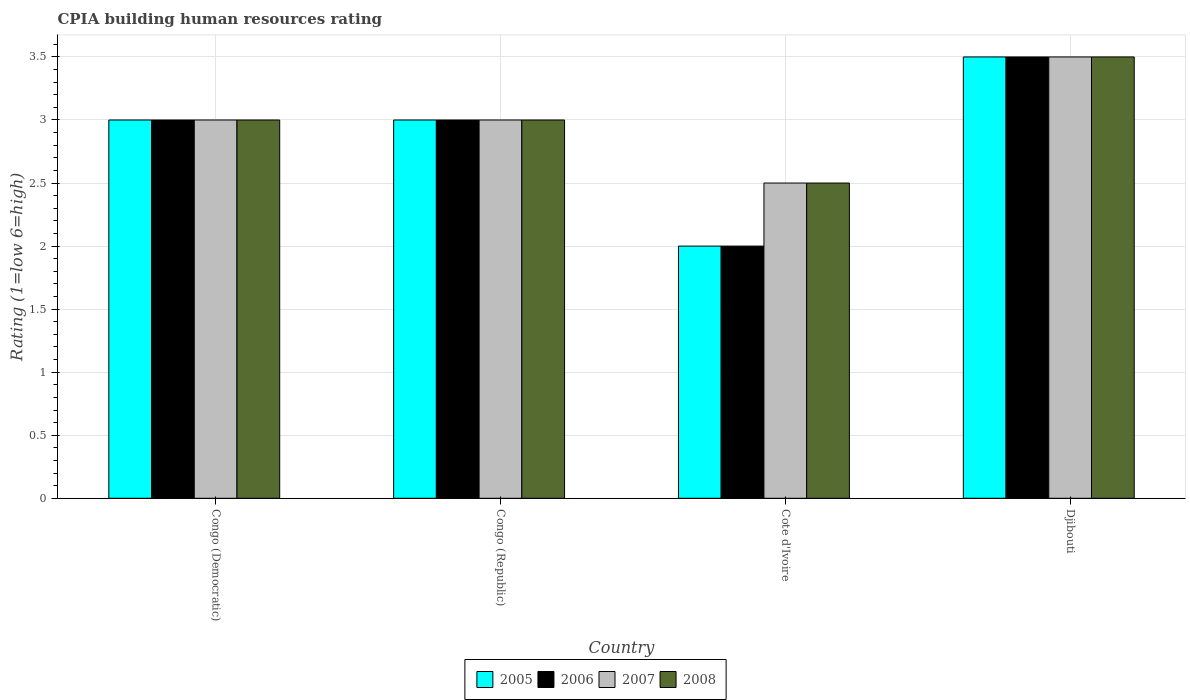How many bars are there on the 2nd tick from the left?
Provide a short and direct response. 4. What is the label of the 2nd group of bars from the left?
Provide a short and direct response. Congo (Republic). What is the CPIA rating in 2008 in Djibouti?
Your response must be concise. 3.5. In which country was the CPIA rating in 2007 maximum?
Keep it short and to the point. Djibouti. In which country was the CPIA rating in 2005 minimum?
Offer a terse response. Cote d'Ivoire. What is the difference between the CPIA rating in 2006 in Congo (Democratic) and that in Congo (Republic)?
Provide a short and direct response. 0. What is the difference between the CPIA rating in 2007 in Djibouti and the CPIA rating in 2005 in Congo (Democratic)?
Your response must be concise. 0.5. What is the average CPIA rating in 2008 per country?
Make the answer very short. 3. In how many countries, is the CPIA rating in 2007 greater than 3.1?
Offer a very short reply. 1. What is the ratio of the CPIA rating in 2006 in Congo (Democratic) to that in Djibouti?
Provide a short and direct response. 0.86. What is the difference between the highest and the second highest CPIA rating in 2008?
Provide a short and direct response. -0.5. What is the difference between the highest and the lowest CPIA rating in 2005?
Provide a short and direct response. 1.5. In how many countries, is the CPIA rating in 2005 greater than the average CPIA rating in 2005 taken over all countries?
Provide a succinct answer. 3. What does the 1st bar from the left in Congo (Republic) represents?
Give a very brief answer. 2005. What does the 2nd bar from the right in Djibouti represents?
Your response must be concise. 2007. What is the difference between two consecutive major ticks on the Y-axis?
Provide a succinct answer. 0.5. Does the graph contain grids?
Your response must be concise. Yes. What is the title of the graph?
Provide a short and direct response. CPIA building human resources rating. What is the label or title of the X-axis?
Provide a succinct answer. Country. What is the Rating (1=low 6=high) in 2006 in Congo (Democratic)?
Your answer should be compact. 3. What is the Rating (1=low 6=high) in 2005 in Congo (Republic)?
Offer a terse response. 3. What is the Rating (1=low 6=high) in 2008 in Congo (Republic)?
Offer a terse response. 3. What is the Rating (1=low 6=high) of 2005 in Cote d'Ivoire?
Give a very brief answer. 2. What is the Rating (1=low 6=high) of 2006 in Cote d'Ivoire?
Your answer should be very brief. 2. What is the Rating (1=low 6=high) of 2008 in Cote d'Ivoire?
Your response must be concise. 2.5. What is the Rating (1=low 6=high) of 2005 in Djibouti?
Your answer should be very brief. 3.5. Across all countries, what is the maximum Rating (1=low 6=high) of 2005?
Your answer should be very brief. 3.5. Across all countries, what is the minimum Rating (1=low 6=high) of 2005?
Provide a short and direct response. 2. Across all countries, what is the minimum Rating (1=low 6=high) in 2007?
Offer a very short reply. 2.5. Across all countries, what is the minimum Rating (1=low 6=high) in 2008?
Keep it short and to the point. 2.5. What is the total Rating (1=low 6=high) of 2005 in the graph?
Ensure brevity in your answer.  11.5. What is the total Rating (1=low 6=high) in 2008 in the graph?
Provide a succinct answer. 12. What is the difference between the Rating (1=low 6=high) of 2005 in Congo (Democratic) and that in Congo (Republic)?
Make the answer very short. 0. What is the difference between the Rating (1=low 6=high) in 2007 in Congo (Democratic) and that in Congo (Republic)?
Offer a very short reply. 0. What is the difference between the Rating (1=low 6=high) of 2008 in Congo (Democratic) and that in Congo (Republic)?
Keep it short and to the point. 0. What is the difference between the Rating (1=low 6=high) of 2005 in Congo (Democratic) and that in Cote d'Ivoire?
Make the answer very short. 1. What is the difference between the Rating (1=low 6=high) in 2006 in Congo (Democratic) and that in Djibouti?
Provide a succinct answer. -0.5. What is the difference between the Rating (1=low 6=high) of 2008 in Congo (Democratic) and that in Djibouti?
Your answer should be very brief. -0.5. What is the difference between the Rating (1=low 6=high) in 2005 in Congo (Republic) and that in Cote d'Ivoire?
Give a very brief answer. 1. What is the difference between the Rating (1=low 6=high) in 2006 in Congo (Republic) and that in Cote d'Ivoire?
Give a very brief answer. 1. What is the difference between the Rating (1=low 6=high) in 2007 in Congo (Republic) and that in Cote d'Ivoire?
Provide a succinct answer. 0.5. What is the difference between the Rating (1=low 6=high) of 2005 in Congo (Republic) and that in Djibouti?
Keep it short and to the point. -0.5. What is the difference between the Rating (1=low 6=high) in 2006 in Congo (Republic) and that in Djibouti?
Provide a short and direct response. -0.5. What is the difference between the Rating (1=low 6=high) of 2007 in Congo (Republic) and that in Djibouti?
Make the answer very short. -0.5. What is the difference between the Rating (1=low 6=high) of 2008 in Congo (Republic) and that in Djibouti?
Offer a very short reply. -0.5. What is the difference between the Rating (1=low 6=high) in 2005 in Cote d'Ivoire and that in Djibouti?
Ensure brevity in your answer.  -1.5. What is the difference between the Rating (1=low 6=high) in 2006 in Cote d'Ivoire and that in Djibouti?
Provide a succinct answer. -1.5. What is the difference between the Rating (1=low 6=high) of 2008 in Cote d'Ivoire and that in Djibouti?
Your response must be concise. -1. What is the difference between the Rating (1=low 6=high) of 2005 in Congo (Democratic) and the Rating (1=low 6=high) of 2008 in Congo (Republic)?
Ensure brevity in your answer.  0. What is the difference between the Rating (1=low 6=high) of 2006 in Congo (Democratic) and the Rating (1=low 6=high) of 2008 in Congo (Republic)?
Keep it short and to the point. 0. What is the difference between the Rating (1=low 6=high) of 2007 in Congo (Democratic) and the Rating (1=low 6=high) of 2008 in Congo (Republic)?
Give a very brief answer. 0. What is the difference between the Rating (1=low 6=high) of 2005 in Congo (Democratic) and the Rating (1=low 6=high) of 2006 in Cote d'Ivoire?
Your answer should be very brief. 1. What is the difference between the Rating (1=low 6=high) of 2005 in Congo (Democratic) and the Rating (1=low 6=high) of 2007 in Cote d'Ivoire?
Keep it short and to the point. 0.5. What is the difference between the Rating (1=low 6=high) in 2005 in Congo (Democratic) and the Rating (1=low 6=high) in 2008 in Cote d'Ivoire?
Ensure brevity in your answer.  0.5. What is the difference between the Rating (1=low 6=high) of 2006 in Congo (Democratic) and the Rating (1=low 6=high) of 2007 in Cote d'Ivoire?
Provide a succinct answer. 0.5. What is the difference between the Rating (1=low 6=high) of 2006 in Congo (Democratic) and the Rating (1=low 6=high) of 2008 in Cote d'Ivoire?
Keep it short and to the point. 0.5. What is the difference between the Rating (1=low 6=high) in 2007 in Congo (Democratic) and the Rating (1=low 6=high) in 2008 in Cote d'Ivoire?
Provide a short and direct response. 0.5. What is the difference between the Rating (1=low 6=high) in 2005 in Congo (Democratic) and the Rating (1=low 6=high) in 2006 in Djibouti?
Provide a short and direct response. -0.5. What is the difference between the Rating (1=low 6=high) of 2006 in Congo (Democratic) and the Rating (1=low 6=high) of 2007 in Djibouti?
Provide a succinct answer. -0.5. What is the difference between the Rating (1=low 6=high) of 2006 in Congo (Democratic) and the Rating (1=low 6=high) of 2008 in Djibouti?
Ensure brevity in your answer.  -0.5. What is the difference between the Rating (1=low 6=high) of 2005 in Congo (Republic) and the Rating (1=low 6=high) of 2006 in Cote d'Ivoire?
Make the answer very short. 1. What is the difference between the Rating (1=low 6=high) in 2005 in Congo (Republic) and the Rating (1=low 6=high) in 2007 in Cote d'Ivoire?
Provide a short and direct response. 0.5. What is the difference between the Rating (1=low 6=high) in 2006 in Congo (Republic) and the Rating (1=low 6=high) in 2007 in Cote d'Ivoire?
Ensure brevity in your answer.  0.5. What is the difference between the Rating (1=low 6=high) of 2007 in Congo (Republic) and the Rating (1=low 6=high) of 2008 in Cote d'Ivoire?
Your response must be concise. 0.5. What is the difference between the Rating (1=low 6=high) of 2005 in Congo (Republic) and the Rating (1=low 6=high) of 2006 in Djibouti?
Offer a terse response. -0.5. What is the difference between the Rating (1=low 6=high) of 2005 in Congo (Republic) and the Rating (1=low 6=high) of 2007 in Djibouti?
Keep it short and to the point. -0.5. What is the difference between the Rating (1=low 6=high) in 2005 in Congo (Republic) and the Rating (1=low 6=high) in 2008 in Djibouti?
Your answer should be compact. -0.5. What is the difference between the Rating (1=low 6=high) in 2006 in Congo (Republic) and the Rating (1=low 6=high) in 2007 in Djibouti?
Keep it short and to the point. -0.5. What is the difference between the Rating (1=low 6=high) of 2006 in Congo (Republic) and the Rating (1=low 6=high) of 2008 in Djibouti?
Make the answer very short. -0.5. What is the difference between the Rating (1=low 6=high) in 2007 in Congo (Republic) and the Rating (1=low 6=high) in 2008 in Djibouti?
Your answer should be compact. -0.5. What is the difference between the Rating (1=low 6=high) of 2005 in Cote d'Ivoire and the Rating (1=low 6=high) of 2006 in Djibouti?
Ensure brevity in your answer.  -1.5. What is the difference between the Rating (1=low 6=high) of 2006 in Cote d'Ivoire and the Rating (1=low 6=high) of 2008 in Djibouti?
Make the answer very short. -1.5. What is the average Rating (1=low 6=high) of 2005 per country?
Provide a short and direct response. 2.88. What is the average Rating (1=low 6=high) of 2006 per country?
Provide a succinct answer. 2.88. What is the average Rating (1=low 6=high) in 2007 per country?
Keep it short and to the point. 3. What is the difference between the Rating (1=low 6=high) of 2005 and Rating (1=low 6=high) of 2007 in Congo (Democratic)?
Your response must be concise. 0. What is the difference between the Rating (1=low 6=high) of 2005 and Rating (1=low 6=high) of 2008 in Congo (Democratic)?
Keep it short and to the point. 0. What is the difference between the Rating (1=low 6=high) of 2006 and Rating (1=low 6=high) of 2008 in Congo (Democratic)?
Provide a succinct answer. 0. What is the difference between the Rating (1=low 6=high) of 2007 and Rating (1=low 6=high) of 2008 in Congo (Democratic)?
Offer a terse response. 0. What is the difference between the Rating (1=low 6=high) of 2005 and Rating (1=low 6=high) of 2008 in Congo (Republic)?
Offer a terse response. 0. What is the difference between the Rating (1=low 6=high) in 2006 and Rating (1=low 6=high) in 2008 in Congo (Republic)?
Your response must be concise. 0. What is the difference between the Rating (1=low 6=high) in 2005 and Rating (1=low 6=high) in 2006 in Cote d'Ivoire?
Your answer should be compact. 0. What is the difference between the Rating (1=low 6=high) in 2005 and Rating (1=low 6=high) in 2007 in Cote d'Ivoire?
Give a very brief answer. -0.5. What is the difference between the Rating (1=low 6=high) of 2005 and Rating (1=low 6=high) of 2008 in Cote d'Ivoire?
Keep it short and to the point. -0.5. What is the difference between the Rating (1=low 6=high) in 2007 and Rating (1=low 6=high) in 2008 in Cote d'Ivoire?
Keep it short and to the point. 0. What is the difference between the Rating (1=low 6=high) in 2005 and Rating (1=low 6=high) in 2007 in Djibouti?
Offer a terse response. 0. What is the difference between the Rating (1=low 6=high) in 2005 and Rating (1=low 6=high) in 2008 in Djibouti?
Provide a succinct answer. 0. What is the difference between the Rating (1=low 6=high) of 2006 and Rating (1=low 6=high) of 2007 in Djibouti?
Offer a very short reply. 0. What is the ratio of the Rating (1=low 6=high) in 2006 in Congo (Democratic) to that in Congo (Republic)?
Your response must be concise. 1. What is the ratio of the Rating (1=low 6=high) of 2007 in Congo (Democratic) to that in Cote d'Ivoire?
Keep it short and to the point. 1.2. What is the ratio of the Rating (1=low 6=high) in 2008 in Congo (Democratic) to that in Cote d'Ivoire?
Your answer should be very brief. 1.2. What is the ratio of the Rating (1=low 6=high) in 2005 in Congo (Democratic) to that in Djibouti?
Give a very brief answer. 0.86. What is the ratio of the Rating (1=low 6=high) of 2006 in Congo (Democratic) to that in Djibouti?
Make the answer very short. 0.86. What is the ratio of the Rating (1=low 6=high) in 2008 in Congo (Democratic) to that in Djibouti?
Your response must be concise. 0.86. What is the ratio of the Rating (1=low 6=high) of 2005 in Congo (Republic) to that in Cote d'Ivoire?
Your answer should be compact. 1.5. What is the ratio of the Rating (1=low 6=high) of 2007 in Congo (Republic) to that in Cote d'Ivoire?
Give a very brief answer. 1.2. What is the ratio of the Rating (1=low 6=high) of 2006 in Congo (Republic) to that in Djibouti?
Make the answer very short. 0.86. What is the ratio of the Rating (1=low 6=high) of 2008 in Congo (Republic) to that in Djibouti?
Provide a succinct answer. 0.86. What is the ratio of the Rating (1=low 6=high) of 2006 in Cote d'Ivoire to that in Djibouti?
Your response must be concise. 0.57. What is the ratio of the Rating (1=low 6=high) in 2007 in Cote d'Ivoire to that in Djibouti?
Your answer should be very brief. 0.71. What is the difference between the highest and the second highest Rating (1=low 6=high) in 2005?
Give a very brief answer. 0.5. What is the difference between the highest and the second highest Rating (1=low 6=high) of 2008?
Offer a terse response. 0.5. What is the difference between the highest and the lowest Rating (1=low 6=high) of 2005?
Provide a succinct answer. 1.5. What is the difference between the highest and the lowest Rating (1=low 6=high) in 2006?
Offer a very short reply. 1.5. What is the difference between the highest and the lowest Rating (1=low 6=high) of 2008?
Give a very brief answer. 1. 